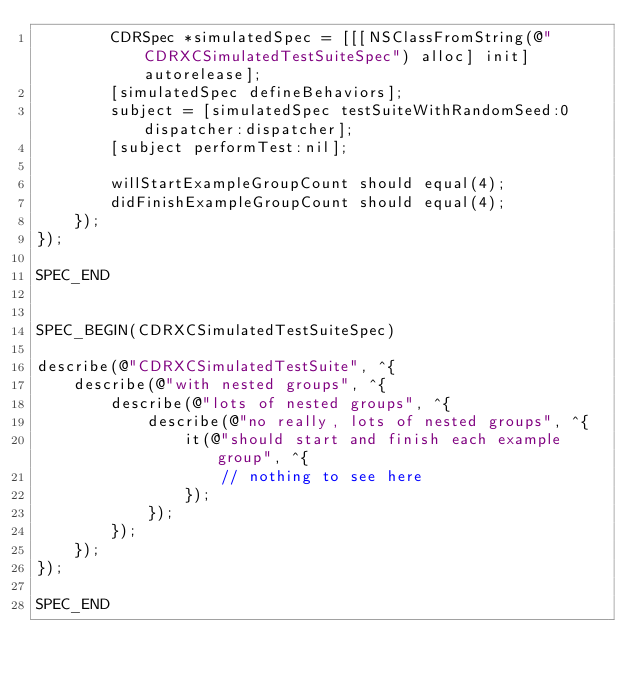<code> <loc_0><loc_0><loc_500><loc_500><_ObjectiveC_>        CDRSpec *simulatedSpec = [[[NSClassFromString(@"CDRXCSimulatedTestSuiteSpec") alloc] init] autorelease];
        [simulatedSpec defineBehaviors];
        subject = [simulatedSpec testSuiteWithRandomSeed:0 dispatcher:dispatcher];
        [subject performTest:nil];

        willStartExampleGroupCount should equal(4);
        didFinishExampleGroupCount should equal(4);
    });
});

SPEC_END


SPEC_BEGIN(CDRXCSimulatedTestSuiteSpec)

describe(@"CDRXCSimulatedTestSuite", ^{
    describe(@"with nested groups", ^{
        describe(@"lots of nested groups", ^{
            describe(@"no really, lots of nested groups", ^{
                it(@"should start and finish each example group", ^{
                    // nothing to see here
                });
            });
        });
    });
});

SPEC_END
</code> 